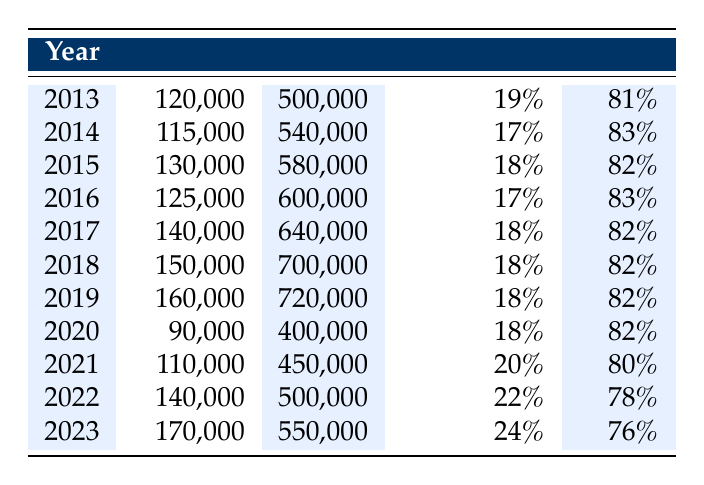What was the classical music attendance in 2022? The table shows the data for the year 2022, where the classical music attendance is listed as 140,000.
Answer: 140,000 What was the pop music attendance in 2016? By referring to the year 2016 in the table, the pop music attendance is recorded as 600,000.
Answer: 600,000 In which year did classical music attendance exceed 160,000? Looking through the table, classical music attendance exceeded 160,000 in 2023 (170,000). The previous years all have lower numbers.
Answer: 2023 What was the total attendance for classical and pop music in 2019? To find this, I add classical attendance (160,000) to pop attendance (720,000) for 2019, giving a total of 160,000 + 720,000 = 880,000.
Answer: 880,000 What percentage of concert attendance for classical music was observed in 2021? In 2021, the classical music percentage from the table is 20% as shown in that row for the year.
Answer: 20% Did classical music attendance increase every year from 2013 to 2023? By analyzing the years, I can see the attendance for classical music varied: it decreased in 2020 (90,000) and did not have a consistent yearly increase. Therefore, the statement is false.
Answer: No Was the percentage of classical music attendance lower than pop music attendance in every year? The percentages indicate that classical music attendance was consistently lower than pop music attendance in every listed year, confirming that this fact is true throughout the decade.
Answer: Yes What is the average classical music attendance from 2013 to 2023? To find the average, I first sum the attendances: 120,000 + 115,000 + 130,000 + 125,000 + 140,000 + 150,000 + 160,000 + 90,000 + 110,000 + 140,000 + 170,000 = 1,500,000. There are 11 years, so the average is 1,500,000 divided by 11, which equals approximately 136,364.
Answer: 136,364 What year had the highest percentage of classical music attendance? The table indicates that in 2023, classical music attendance was at 24%, which is the highest percentage recorded in the provided years.
Answer: 2023 